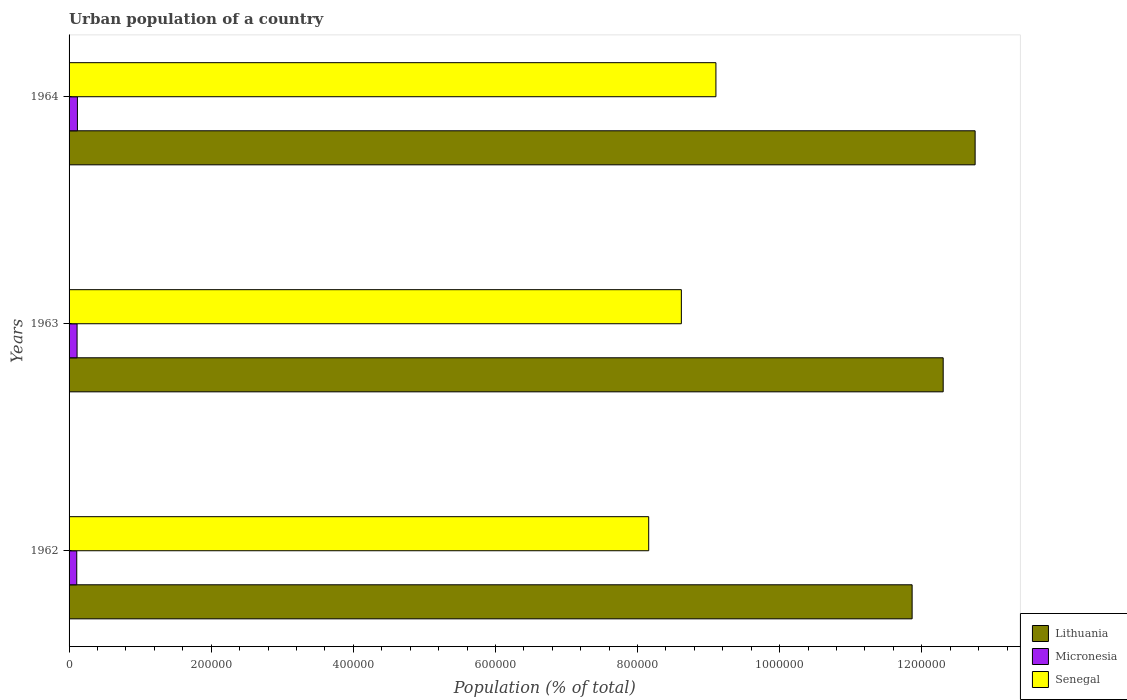How many groups of bars are there?
Ensure brevity in your answer.  3. Are the number of bars on each tick of the Y-axis equal?
Offer a terse response. Yes. In how many cases, is the number of bars for a given year not equal to the number of legend labels?
Offer a terse response. 0. What is the urban population in Micronesia in 1963?
Give a very brief answer. 1.13e+04. Across all years, what is the maximum urban population in Lithuania?
Ensure brevity in your answer.  1.28e+06. Across all years, what is the minimum urban population in Senegal?
Keep it short and to the point. 8.16e+05. In which year was the urban population in Micronesia maximum?
Your response must be concise. 1964. In which year was the urban population in Lithuania minimum?
Make the answer very short. 1962. What is the total urban population in Senegal in the graph?
Provide a short and direct response. 2.59e+06. What is the difference between the urban population in Micronesia in 1962 and that in 1964?
Offer a terse response. -954. What is the difference between the urban population in Lithuania in 1962 and the urban population in Micronesia in 1963?
Give a very brief answer. 1.18e+06. What is the average urban population in Lithuania per year?
Your answer should be compact. 1.23e+06. In the year 1962, what is the difference between the urban population in Lithuania and urban population in Micronesia?
Provide a short and direct response. 1.18e+06. In how many years, is the urban population in Micronesia greater than 480000 %?
Your response must be concise. 0. What is the ratio of the urban population in Micronesia in 1963 to that in 1964?
Ensure brevity in your answer.  0.96. Is the urban population in Lithuania in 1962 less than that in 1963?
Offer a terse response. Yes. What is the difference between the highest and the second highest urban population in Micronesia?
Your answer should be very brief. 495. What is the difference between the highest and the lowest urban population in Senegal?
Give a very brief answer. 9.46e+04. Is the sum of the urban population in Lithuania in 1962 and 1963 greater than the maximum urban population in Senegal across all years?
Offer a very short reply. Yes. What does the 1st bar from the top in 1962 represents?
Provide a short and direct response. Senegal. What does the 1st bar from the bottom in 1964 represents?
Provide a succinct answer. Lithuania. Does the graph contain any zero values?
Ensure brevity in your answer.  No. How many legend labels are there?
Offer a very short reply. 3. What is the title of the graph?
Give a very brief answer. Urban population of a country. What is the label or title of the X-axis?
Provide a succinct answer. Population (% of total). What is the Population (% of total) of Lithuania in 1962?
Offer a very short reply. 1.19e+06. What is the Population (% of total) in Micronesia in 1962?
Ensure brevity in your answer.  1.08e+04. What is the Population (% of total) of Senegal in 1962?
Offer a very short reply. 8.16e+05. What is the Population (% of total) in Lithuania in 1963?
Provide a short and direct response. 1.23e+06. What is the Population (% of total) in Micronesia in 1963?
Offer a terse response. 1.13e+04. What is the Population (% of total) in Senegal in 1963?
Provide a short and direct response. 8.62e+05. What is the Population (% of total) in Lithuania in 1964?
Your answer should be compact. 1.28e+06. What is the Population (% of total) in Micronesia in 1964?
Your response must be concise. 1.18e+04. What is the Population (% of total) of Senegal in 1964?
Keep it short and to the point. 9.10e+05. Across all years, what is the maximum Population (% of total) in Lithuania?
Provide a succinct answer. 1.28e+06. Across all years, what is the maximum Population (% of total) in Micronesia?
Your answer should be very brief. 1.18e+04. Across all years, what is the maximum Population (% of total) in Senegal?
Offer a very short reply. 9.10e+05. Across all years, what is the minimum Population (% of total) in Lithuania?
Your answer should be compact. 1.19e+06. Across all years, what is the minimum Population (% of total) in Micronesia?
Make the answer very short. 1.08e+04. Across all years, what is the minimum Population (% of total) of Senegal?
Your answer should be very brief. 8.16e+05. What is the total Population (% of total) in Lithuania in the graph?
Keep it short and to the point. 3.69e+06. What is the total Population (% of total) in Micronesia in the graph?
Offer a very short reply. 3.38e+04. What is the total Population (% of total) in Senegal in the graph?
Offer a very short reply. 2.59e+06. What is the difference between the Population (% of total) of Lithuania in 1962 and that in 1963?
Your answer should be very brief. -4.37e+04. What is the difference between the Population (% of total) in Micronesia in 1962 and that in 1963?
Offer a terse response. -459. What is the difference between the Population (% of total) of Senegal in 1962 and that in 1963?
Make the answer very short. -4.60e+04. What is the difference between the Population (% of total) in Lithuania in 1962 and that in 1964?
Offer a terse response. -8.87e+04. What is the difference between the Population (% of total) in Micronesia in 1962 and that in 1964?
Ensure brevity in your answer.  -954. What is the difference between the Population (% of total) in Senegal in 1962 and that in 1964?
Make the answer very short. -9.46e+04. What is the difference between the Population (% of total) in Lithuania in 1963 and that in 1964?
Your answer should be compact. -4.49e+04. What is the difference between the Population (% of total) of Micronesia in 1963 and that in 1964?
Offer a terse response. -495. What is the difference between the Population (% of total) in Senegal in 1963 and that in 1964?
Make the answer very short. -4.86e+04. What is the difference between the Population (% of total) of Lithuania in 1962 and the Population (% of total) of Micronesia in 1963?
Offer a terse response. 1.18e+06. What is the difference between the Population (% of total) of Lithuania in 1962 and the Population (% of total) of Senegal in 1963?
Your response must be concise. 3.25e+05. What is the difference between the Population (% of total) in Micronesia in 1962 and the Population (% of total) in Senegal in 1963?
Ensure brevity in your answer.  -8.51e+05. What is the difference between the Population (% of total) of Lithuania in 1962 and the Population (% of total) of Micronesia in 1964?
Offer a terse response. 1.17e+06. What is the difference between the Population (% of total) in Lithuania in 1962 and the Population (% of total) in Senegal in 1964?
Ensure brevity in your answer.  2.76e+05. What is the difference between the Population (% of total) of Micronesia in 1962 and the Population (% of total) of Senegal in 1964?
Offer a very short reply. -8.99e+05. What is the difference between the Population (% of total) of Lithuania in 1963 and the Population (% of total) of Micronesia in 1964?
Make the answer very short. 1.22e+06. What is the difference between the Population (% of total) in Lithuania in 1963 and the Population (% of total) in Senegal in 1964?
Offer a terse response. 3.20e+05. What is the difference between the Population (% of total) in Micronesia in 1963 and the Population (% of total) in Senegal in 1964?
Offer a very short reply. -8.99e+05. What is the average Population (% of total) of Lithuania per year?
Offer a very short reply. 1.23e+06. What is the average Population (% of total) of Micronesia per year?
Your answer should be very brief. 1.13e+04. What is the average Population (% of total) of Senegal per year?
Provide a succinct answer. 8.63e+05. In the year 1962, what is the difference between the Population (% of total) of Lithuania and Population (% of total) of Micronesia?
Keep it short and to the point. 1.18e+06. In the year 1962, what is the difference between the Population (% of total) of Lithuania and Population (% of total) of Senegal?
Your response must be concise. 3.71e+05. In the year 1962, what is the difference between the Population (% of total) of Micronesia and Population (% of total) of Senegal?
Give a very brief answer. -8.05e+05. In the year 1963, what is the difference between the Population (% of total) of Lithuania and Population (% of total) of Micronesia?
Provide a short and direct response. 1.22e+06. In the year 1963, what is the difference between the Population (% of total) of Lithuania and Population (% of total) of Senegal?
Offer a terse response. 3.68e+05. In the year 1963, what is the difference between the Population (% of total) in Micronesia and Population (% of total) in Senegal?
Your answer should be compact. -8.50e+05. In the year 1964, what is the difference between the Population (% of total) in Lithuania and Population (% of total) in Micronesia?
Your answer should be compact. 1.26e+06. In the year 1964, what is the difference between the Population (% of total) of Lithuania and Population (% of total) of Senegal?
Your answer should be very brief. 3.65e+05. In the year 1964, what is the difference between the Population (% of total) in Micronesia and Population (% of total) in Senegal?
Your answer should be compact. -8.99e+05. What is the ratio of the Population (% of total) of Lithuania in 1962 to that in 1963?
Your response must be concise. 0.96. What is the ratio of the Population (% of total) of Micronesia in 1962 to that in 1963?
Offer a very short reply. 0.96. What is the ratio of the Population (% of total) in Senegal in 1962 to that in 1963?
Make the answer very short. 0.95. What is the ratio of the Population (% of total) of Lithuania in 1962 to that in 1964?
Offer a very short reply. 0.93. What is the ratio of the Population (% of total) in Micronesia in 1962 to that in 1964?
Your answer should be compact. 0.92. What is the ratio of the Population (% of total) in Senegal in 1962 to that in 1964?
Keep it short and to the point. 0.9. What is the ratio of the Population (% of total) in Lithuania in 1963 to that in 1964?
Your answer should be compact. 0.96. What is the ratio of the Population (% of total) of Micronesia in 1963 to that in 1964?
Offer a terse response. 0.96. What is the ratio of the Population (% of total) of Senegal in 1963 to that in 1964?
Make the answer very short. 0.95. What is the difference between the highest and the second highest Population (% of total) in Lithuania?
Keep it short and to the point. 4.49e+04. What is the difference between the highest and the second highest Population (% of total) of Micronesia?
Your response must be concise. 495. What is the difference between the highest and the second highest Population (% of total) in Senegal?
Provide a short and direct response. 4.86e+04. What is the difference between the highest and the lowest Population (% of total) in Lithuania?
Ensure brevity in your answer.  8.87e+04. What is the difference between the highest and the lowest Population (% of total) of Micronesia?
Offer a very short reply. 954. What is the difference between the highest and the lowest Population (% of total) of Senegal?
Give a very brief answer. 9.46e+04. 